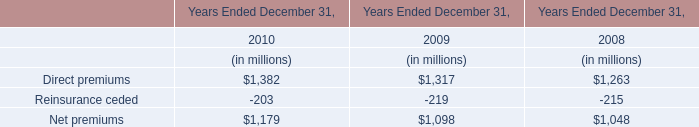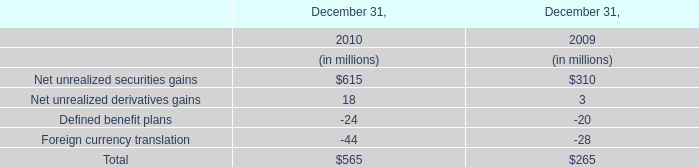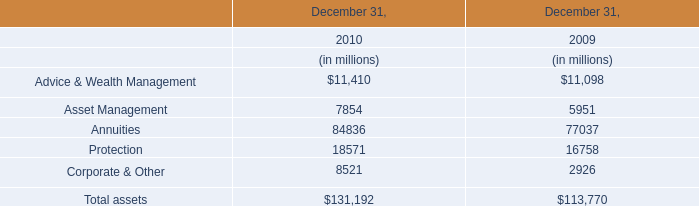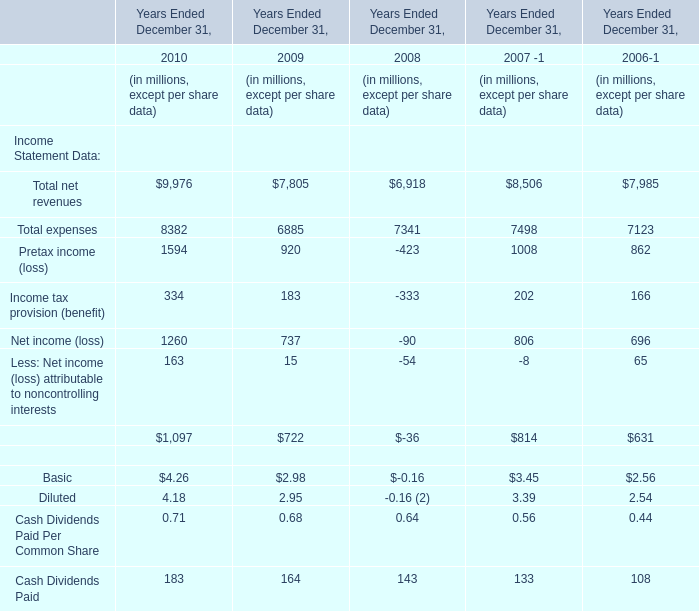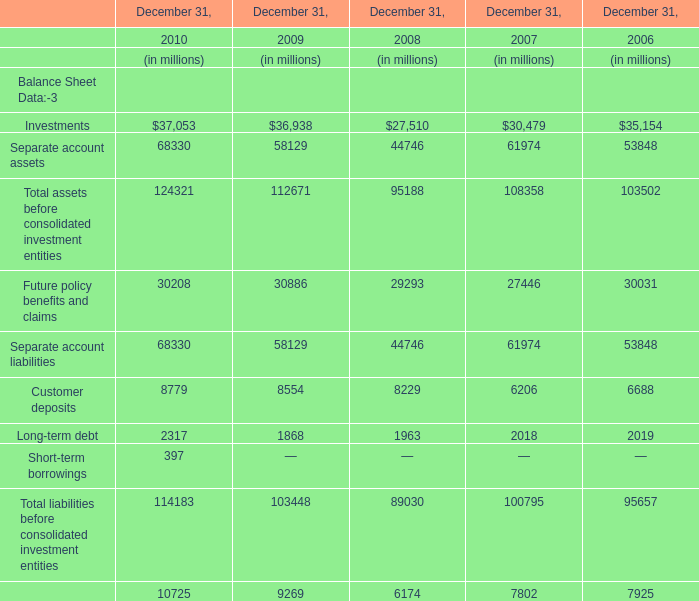What's the sum of assets before consolidated investment entities in 2010 ? (in million) 
Computations: (37053 + 68330)
Answer: 105383.0. 